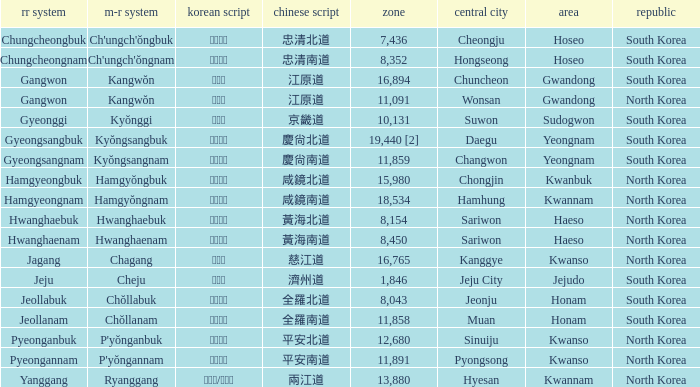Which capital has a Hangul of 경상남도? Changwon. 